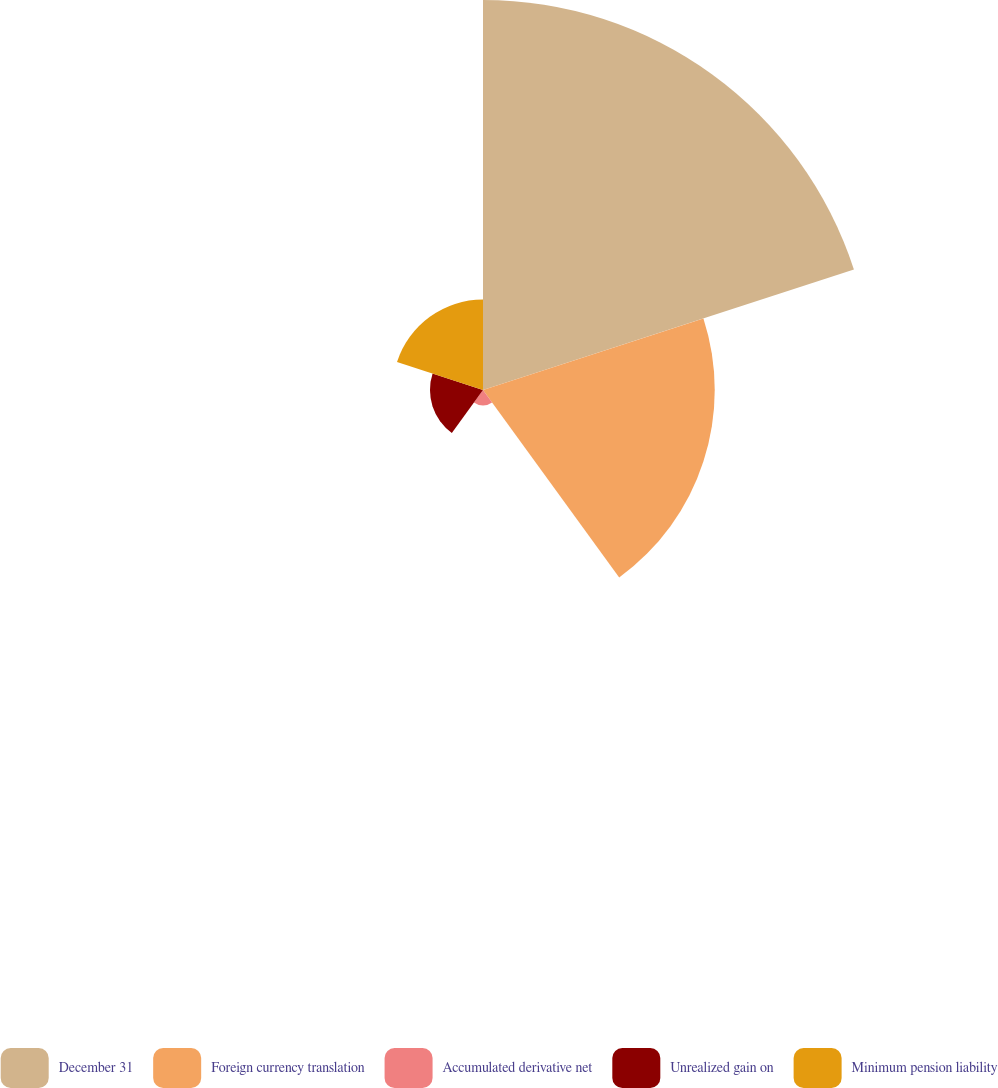Convert chart to OTSL. <chart><loc_0><loc_0><loc_500><loc_500><pie_chart><fcel>December 31<fcel>Foreign currency translation<fcel>Accumulated derivative net<fcel>Unrealized gain on<fcel>Minimum pension liability<nl><fcel>49.95%<fcel>29.68%<fcel>1.99%<fcel>6.79%<fcel>11.58%<nl></chart> 